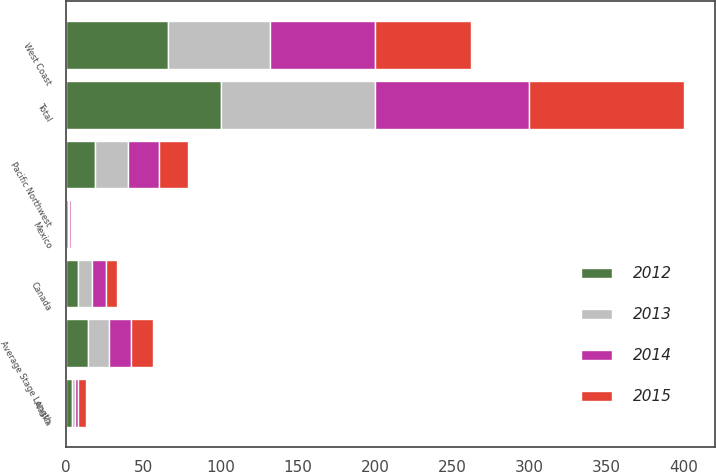<chart> <loc_0><loc_0><loc_500><loc_500><stacked_bar_chart><ecel><fcel>West Coast<fcel>Pacific Northwest<fcel>Canada<fcel>Alaska<fcel>Mexico<fcel>Total<fcel>Average Stage Length<nl><fcel>2015<fcel>62<fcel>19<fcel>7<fcel>5<fcel>1<fcel>100<fcel>14<nl><fcel>2012<fcel>66<fcel>19<fcel>8<fcel>4<fcel>1<fcel>100<fcel>14<nl><fcel>2013<fcel>66<fcel>21<fcel>9<fcel>2<fcel>1<fcel>100<fcel>14<nl><fcel>2014<fcel>68<fcel>20<fcel>9<fcel>2<fcel>1<fcel>100<fcel>14<nl></chart> 